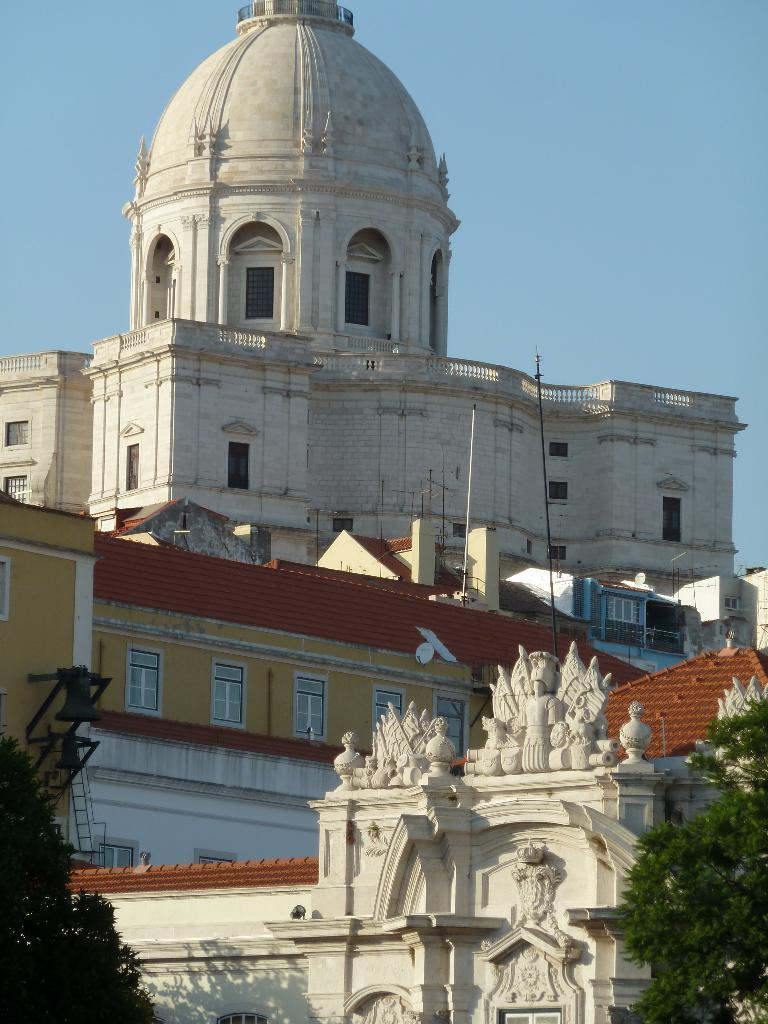What type of structures can be seen in the image? There are buildings in the image. Where are the trees located in the image? The trees are at the right bottom and left bottom of the image. What is visible at the top of the image? The sky is visible at the top of the image. Can you tell me how many trays are being pushed by the buildings in the image? There are no trays or pushing actions depicted in the image; it features buildings, trees, and the sky. 